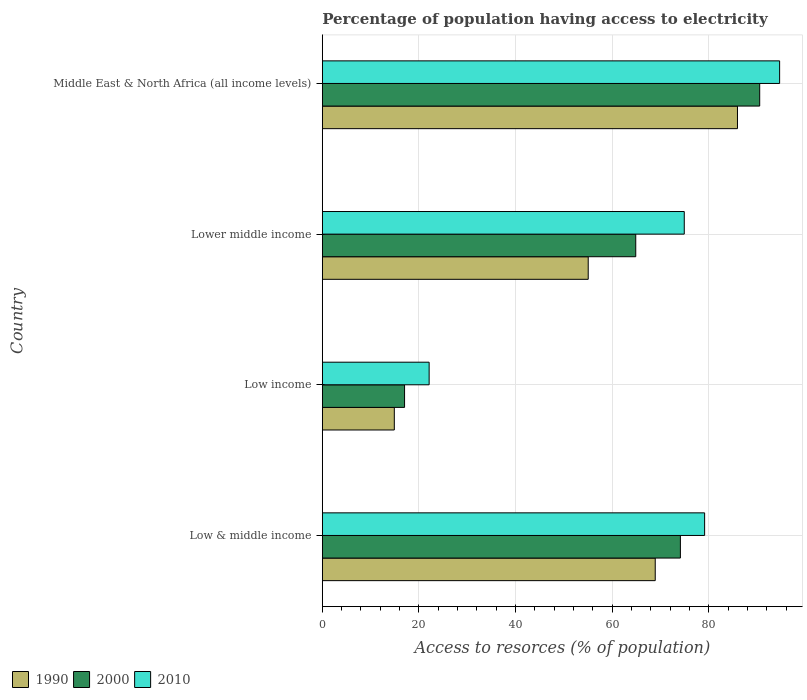How many different coloured bars are there?
Provide a succinct answer. 3. Are the number of bars per tick equal to the number of legend labels?
Your response must be concise. Yes. Are the number of bars on each tick of the Y-axis equal?
Make the answer very short. Yes. How many bars are there on the 1st tick from the top?
Offer a very short reply. 3. In how many cases, is the number of bars for a given country not equal to the number of legend labels?
Your answer should be very brief. 0. What is the percentage of population having access to electricity in 2000 in Middle East & North Africa (all income levels)?
Your answer should be very brief. 90.5. Across all countries, what is the maximum percentage of population having access to electricity in 1990?
Your answer should be very brief. 85.9. Across all countries, what is the minimum percentage of population having access to electricity in 1990?
Offer a very short reply. 14.9. In which country was the percentage of population having access to electricity in 2000 maximum?
Ensure brevity in your answer.  Middle East & North Africa (all income levels). In which country was the percentage of population having access to electricity in 2000 minimum?
Ensure brevity in your answer.  Low income. What is the total percentage of population having access to electricity in 2000 in the graph?
Provide a short and direct response. 246.46. What is the difference between the percentage of population having access to electricity in 1990 in Lower middle income and that in Middle East & North Africa (all income levels)?
Your answer should be compact. -30.88. What is the difference between the percentage of population having access to electricity in 2000 in Lower middle income and the percentage of population having access to electricity in 1990 in Low & middle income?
Your answer should be compact. -4.03. What is the average percentage of population having access to electricity in 2000 per country?
Provide a succinct answer. 61.61. What is the difference between the percentage of population having access to electricity in 2000 and percentage of population having access to electricity in 2010 in Lower middle income?
Offer a very short reply. -10.04. What is the ratio of the percentage of population having access to electricity in 1990 in Low & middle income to that in Lower middle income?
Offer a very short reply. 1.25. Is the percentage of population having access to electricity in 1990 in Low & middle income less than that in Lower middle income?
Offer a very short reply. No. Is the difference between the percentage of population having access to electricity in 2000 in Low & middle income and Middle East & North Africa (all income levels) greater than the difference between the percentage of population having access to electricity in 2010 in Low & middle income and Middle East & North Africa (all income levels)?
Ensure brevity in your answer.  No. What is the difference between the highest and the second highest percentage of population having access to electricity in 2010?
Your response must be concise. 15.52. What is the difference between the highest and the lowest percentage of population having access to electricity in 2000?
Your answer should be compact. 73.49. Is the sum of the percentage of population having access to electricity in 1990 in Low income and Middle East & North Africa (all income levels) greater than the maximum percentage of population having access to electricity in 2000 across all countries?
Offer a terse response. Yes. What does the 1st bar from the bottom in Low income represents?
Keep it short and to the point. 1990. Is it the case that in every country, the sum of the percentage of population having access to electricity in 2010 and percentage of population having access to electricity in 2000 is greater than the percentage of population having access to electricity in 1990?
Provide a short and direct response. Yes. How many bars are there?
Provide a succinct answer. 12. Are all the bars in the graph horizontal?
Keep it short and to the point. Yes. How many countries are there in the graph?
Ensure brevity in your answer.  4. What is the difference between two consecutive major ticks on the X-axis?
Your answer should be compact. 20. Are the values on the major ticks of X-axis written in scientific E-notation?
Your answer should be compact. No. How are the legend labels stacked?
Provide a succinct answer. Horizontal. What is the title of the graph?
Your response must be concise. Percentage of population having access to electricity. What is the label or title of the X-axis?
Offer a very short reply. Access to resorces (% of population). What is the Access to resorces (% of population) of 1990 in Low & middle income?
Your answer should be compact. 68.89. What is the Access to resorces (% of population) in 2000 in Low & middle income?
Your answer should be very brief. 74.09. What is the Access to resorces (% of population) in 2010 in Low & middle income?
Make the answer very short. 79.11. What is the Access to resorces (% of population) in 1990 in Low income?
Ensure brevity in your answer.  14.9. What is the Access to resorces (% of population) of 2000 in Low income?
Your response must be concise. 17.01. What is the Access to resorces (% of population) of 2010 in Low income?
Offer a terse response. 22.1. What is the Access to resorces (% of population) of 1990 in Lower middle income?
Keep it short and to the point. 55.02. What is the Access to resorces (% of population) in 2000 in Lower middle income?
Make the answer very short. 64.85. What is the Access to resorces (% of population) in 2010 in Lower middle income?
Your response must be concise. 74.89. What is the Access to resorces (% of population) of 1990 in Middle East & North Africa (all income levels)?
Your answer should be compact. 85.9. What is the Access to resorces (% of population) in 2000 in Middle East & North Africa (all income levels)?
Keep it short and to the point. 90.5. What is the Access to resorces (% of population) in 2010 in Middle East & North Africa (all income levels)?
Make the answer very short. 94.62. Across all countries, what is the maximum Access to resorces (% of population) in 1990?
Offer a terse response. 85.9. Across all countries, what is the maximum Access to resorces (% of population) of 2000?
Offer a very short reply. 90.5. Across all countries, what is the maximum Access to resorces (% of population) in 2010?
Provide a succinct answer. 94.62. Across all countries, what is the minimum Access to resorces (% of population) in 1990?
Provide a short and direct response. 14.9. Across all countries, what is the minimum Access to resorces (% of population) of 2000?
Give a very brief answer. 17.01. Across all countries, what is the minimum Access to resorces (% of population) of 2010?
Provide a short and direct response. 22.1. What is the total Access to resorces (% of population) of 1990 in the graph?
Keep it short and to the point. 224.7. What is the total Access to resorces (% of population) in 2000 in the graph?
Your answer should be compact. 246.46. What is the total Access to resorces (% of population) of 2010 in the graph?
Give a very brief answer. 270.72. What is the difference between the Access to resorces (% of population) of 1990 in Low & middle income and that in Low income?
Keep it short and to the point. 53.99. What is the difference between the Access to resorces (% of population) in 2000 in Low & middle income and that in Low income?
Make the answer very short. 57.07. What is the difference between the Access to resorces (% of population) of 2010 in Low & middle income and that in Low income?
Offer a very short reply. 57. What is the difference between the Access to resorces (% of population) of 1990 in Low & middle income and that in Lower middle income?
Make the answer very short. 13.87. What is the difference between the Access to resorces (% of population) of 2000 in Low & middle income and that in Lower middle income?
Keep it short and to the point. 9.24. What is the difference between the Access to resorces (% of population) of 2010 in Low & middle income and that in Lower middle income?
Your response must be concise. 4.21. What is the difference between the Access to resorces (% of population) in 1990 in Low & middle income and that in Middle East & North Africa (all income levels)?
Offer a very short reply. -17.01. What is the difference between the Access to resorces (% of population) of 2000 in Low & middle income and that in Middle East & North Africa (all income levels)?
Offer a terse response. -16.41. What is the difference between the Access to resorces (% of population) of 2010 in Low & middle income and that in Middle East & North Africa (all income levels)?
Keep it short and to the point. -15.52. What is the difference between the Access to resorces (% of population) of 1990 in Low income and that in Lower middle income?
Your answer should be compact. -40.12. What is the difference between the Access to resorces (% of population) in 2000 in Low income and that in Lower middle income?
Provide a succinct answer. -47.84. What is the difference between the Access to resorces (% of population) of 2010 in Low income and that in Lower middle income?
Your answer should be compact. -52.79. What is the difference between the Access to resorces (% of population) in 1990 in Low income and that in Middle East & North Africa (all income levels)?
Ensure brevity in your answer.  -71. What is the difference between the Access to resorces (% of population) in 2000 in Low income and that in Middle East & North Africa (all income levels)?
Your answer should be very brief. -73.49. What is the difference between the Access to resorces (% of population) in 2010 in Low income and that in Middle East & North Africa (all income levels)?
Your response must be concise. -72.52. What is the difference between the Access to resorces (% of population) in 1990 in Lower middle income and that in Middle East & North Africa (all income levels)?
Ensure brevity in your answer.  -30.88. What is the difference between the Access to resorces (% of population) in 2000 in Lower middle income and that in Middle East & North Africa (all income levels)?
Ensure brevity in your answer.  -25.65. What is the difference between the Access to resorces (% of population) in 2010 in Lower middle income and that in Middle East & North Africa (all income levels)?
Your answer should be very brief. -19.73. What is the difference between the Access to resorces (% of population) in 1990 in Low & middle income and the Access to resorces (% of population) in 2000 in Low income?
Offer a very short reply. 51.87. What is the difference between the Access to resorces (% of population) of 1990 in Low & middle income and the Access to resorces (% of population) of 2010 in Low income?
Ensure brevity in your answer.  46.79. What is the difference between the Access to resorces (% of population) in 2000 in Low & middle income and the Access to resorces (% of population) in 2010 in Low income?
Your response must be concise. 51.99. What is the difference between the Access to resorces (% of population) in 1990 in Low & middle income and the Access to resorces (% of population) in 2000 in Lower middle income?
Make the answer very short. 4.03. What is the difference between the Access to resorces (% of population) in 1990 in Low & middle income and the Access to resorces (% of population) in 2010 in Lower middle income?
Offer a terse response. -6.01. What is the difference between the Access to resorces (% of population) in 2000 in Low & middle income and the Access to resorces (% of population) in 2010 in Lower middle income?
Ensure brevity in your answer.  -0.8. What is the difference between the Access to resorces (% of population) of 1990 in Low & middle income and the Access to resorces (% of population) of 2000 in Middle East & North Africa (all income levels)?
Offer a terse response. -21.61. What is the difference between the Access to resorces (% of population) in 1990 in Low & middle income and the Access to resorces (% of population) in 2010 in Middle East & North Africa (all income levels)?
Your response must be concise. -25.74. What is the difference between the Access to resorces (% of population) in 2000 in Low & middle income and the Access to resorces (% of population) in 2010 in Middle East & North Africa (all income levels)?
Provide a short and direct response. -20.54. What is the difference between the Access to resorces (% of population) of 1990 in Low income and the Access to resorces (% of population) of 2000 in Lower middle income?
Provide a succinct answer. -49.96. What is the difference between the Access to resorces (% of population) in 1990 in Low income and the Access to resorces (% of population) in 2010 in Lower middle income?
Provide a short and direct response. -60. What is the difference between the Access to resorces (% of population) in 2000 in Low income and the Access to resorces (% of population) in 2010 in Lower middle income?
Offer a very short reply. -57.88. What is the difference between the Access to resorces (% of population) in 1990 in Low income and the Access to resorces (% of population) in 2000 in Middle East & North Africa (all income levels)?
Provide a short and direct response. -75.6. What is the difference between the Access to resorces (% of population) of 1990 in Low income and the Access to resorces (% of population) of 2010 in Middle East & North Africa (all income levels)?
Your answer should be compact. -79.73. What is the difference between the Access to resorces (% of population) in 2000 in Low income and the Access to resorces (% of population) in 2010 in Middle East & North Africa (all income levels)?
Make the answer very short. -77.61. What is the difference between the Access to resorces (% of population) in 1990 in Lower middle income and the Access to resorces (% of population) in 2000 in Middle East & North Africa (all income levels)?
Provide a short and direct response. -35.48. What is the difference between the Access to resorces (% of population) in 1990 in Lower middle income and the Access to resorces (% of population) in 2010 in Middle East & North Africa (all income levels)?
Keep it short and to the point. -39.61. What is the difference between the Access to resorces (% of population) in 2000 in Lower middle income and the Access to resorces (% of population) in 2010 in Middle East & North Africa (all income levels)?
Offer a very short reply. -29.77. What is the average Access to resorces (% of population) in 1990 per country?
Provide a short and direct response. 56.17. What is the average Access to resorces (% of population) of 2000 per country?
Make the answer very short. 61.61. What is the average Access to resorces (% of population) of 2010 per country?
Provide a succinct answer. 67.68. What is the difference between the Access to resorces (% of population) in 1990 and Access to resorces (% of population) in 2000 in Low & middle income?
Your answer should be very brief. -5.2. What is the difference between the Access to resorces (% of population) of 1990 and Access to resorces (% of population) of 2010 in Low & middle income?
Provide a succinct answer. -10.22. What is the difference between the Access to resorces (% of population) of 2000 and Access to resorces (% of population) of 2010 in Low & middle income?
Ensure brevity in your answer.  -5.02. What is the difference between the Access to resorces (% of population) in 1990 and Access to resorces (% of population) in 2000 in Low income?
Your answer should be compact. -2.12. What is the difference between the Access to resorces (% of population) of 1990 and Access to resorces (% of population) of 2010 in Low income?
Provide a succinct answer. -7.2. What is the difference between the Access to resorces (% of population) in 2000 and Access to resorces (% of population) in 2010 in Low income?
Your answer should be very brief. -5.09. What is the difference between the Access to resorces (% of population) in 1990 and Access to resorces (% of population) in 2000 in Lower middle income?
Ensure brevity in your answer.  -9.84. What is the difference between the Access to resorces (% of population) in 1990 and Access to resorces (% of population) in 2010 in Lower middle income?
Your answer should be compact. -19.87. What is the difference between the Access to resorces (% of population) in 2000 and Access to resorces (% of population) in 2010 in Lower middle income?
Provide a succinct answer. -10.04. What is the difference between the Access to resorces (% of population) in 1990 and Access to resorces (% of population) in 2000 in Middle East & North Africa (all income levels)?
Your answer should be very brief. -4.6. What is the difference between the Access to resorces (% of population) in 1990 and Access to resorces (% of population) in 2010 in Middle East & North Africa (all income levels)?
Keep it short and to the point. -8.73. What is the difference between the Access to resorces (% of population) of 2000 and Access to resorces (% of population) of 2010 in Middle East & North Africa (all income levels)?
Keep it short and to the point. -4.12. What is the ratio of the Access to resorces (% of population) of 1990 in Low & middle income to that in Low income?
Your answer should be very brief. 4.62. What is the ratio of the Access to resorces (% of population) of 2000 in Low & middle income to that in Low income?
Make the answer very short. 4.35. What is the ratio of the Access to resorces (% of population) of 2010 in Low & middle income to that in Low income?
Your answer should be very brief. 3.58. What is the ratio of the Access to resorces (% of population) in 1990 in Low & middle income to that in Lower middle income?
Offer a terse response. 1.25. What is the ratio of the Access to resorces (% of population) in 2000 in Low & middle income to that in Lower middle income?
Keep it short and to the point. 1.14. What is the ratio of the Access to resorces (% of population) in 2010 in Low & middle income to that in Lower middle income?
Provide a succinct answer. 1.06. What is the ratio of the Access to resorces (% of population) in 1990 in Low & middle income to that in Middle East & North Africa (all income levels)?
Provide a succinct answer. 0.8. What is the ratio of the Access to resorces (% of population) of 2000 in Low & middle income to that in Middle East & North Africa (all income levels)?
Offer a terse response. 0.82. What is the ratio of the Access to resorces (% of population) in 2010 in Low & middle income to that in Middle East & North Africa (all income levels)?
Keep it short and to the point. 0.84. What is the ratio of the Access to resorces (% of population) in 1990 in Low income to that in Lower middle income?
Give a very brief answer. 0.27. What is the ratio of the Access to resorces (% of population) in 2000 in Low income to that in Lower middle income?
Give a very brief answer. 0.26. What is the ratio of the Access to resorces (% of population) in 2010 in Low income to that in Lower middle income?
Your answer should be very brief. 0.3. What is the ratio of the Access to resorces (% of population) in 1990 in Low income to that in Middle East & North Africa (all income levels)?
Provide a succinct answer. 0.17. What is the ratio of the Access to resorces (% of population) of 2000 in Low income to that in Middle East & North Africa (all income levels)?
Keep it short and to the point. 0.19. What is the ratio of the Access to resorces (% of population) of 2010 in Low income to that in Middle East & North Africa (all income levels)?
Provide a succinct answer. 0.23. What is the ratio of the Access to resorces (% of population) in 1990 in Lower middle income to that in Middle East & North Africa (all income levels)?
Provide a succinct answer. 0.64. What is the ratio of the Access to resorces (% of population) in 2000 in Lower middle income to that in Middle East & North Africa (all income levels)?
Keep it short and to the point. 0.72. What is the ratio of the Access to resorces (% of population) in 2010 in Lower middle income to that in Middle East & North Africa (all income levels)?
Give a very brief answer. 0.79. What is the difference between the highest and the second highest Access to resorces (% of population) of 1990?
Your answer should be compact. 17.01. What is the difference between the highest and the second highest Access to resorces (% of population) of 2000?
Make the answer very short. 16.41. What is the difference between the highest and the second highest Access to resorces (% of population) of 2010?
Keep it short and to the point. 15.52. What is the difference between the highest and the lowest Access to resorces (% of population) of 1990?
Provide a short and direct response. 71. What is the difference between the highest and the lowest Access to resorces (% of population) in 2000?
Your answer should be compact. 73.49. What is the difference between the highest and the lowest Access to resorces (% of population) in 2010?
Ensure brevity in your answer.  72.52. 